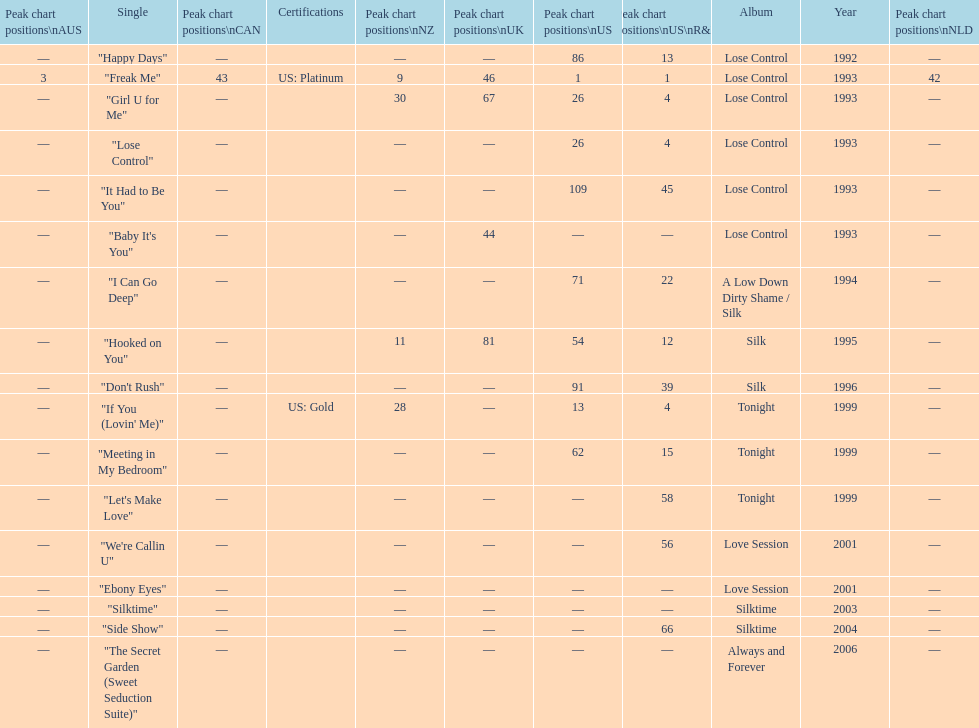Compare "i can go deep" with "don't rush". which was higher on the us and us r&b charts? "I Can Go Deep". 